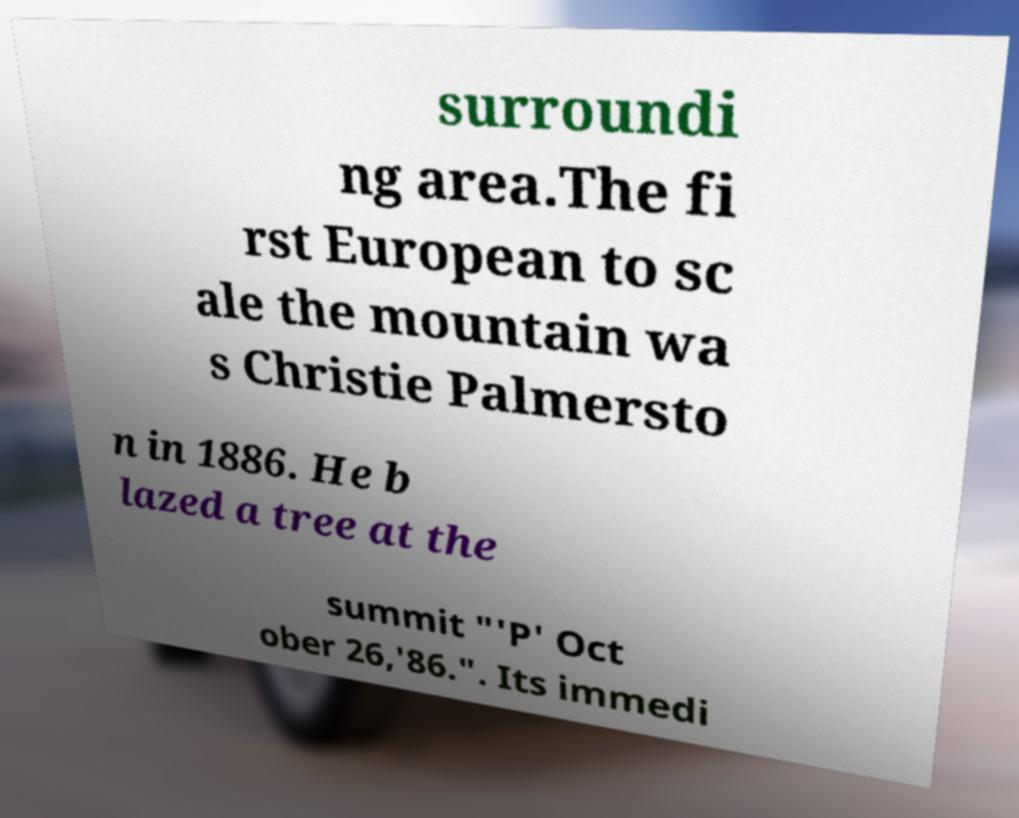What messages or text are displayed in this image? I need them in a readable, typed format. surroundi ng area.The fi rst European to sc ale the mountain wa s Christie Palmersto n in 1886. He b lazed a tree at the summit "'P' Oct ober 26,'86.". Its immedi 